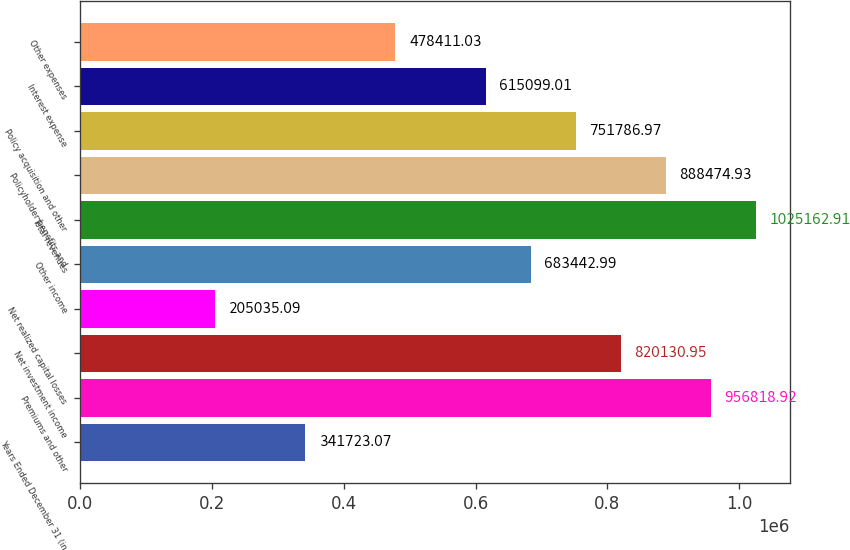<chart> <loc_0><loc_0><loc_500><loc_500><bar_chart><fcel>Years Ended December 31 (in<fcel>Premiums and other<fcel>Net investment income<fcel>Net realized capital losses<fcel>Other income<fcel>Total revenues<fcel>Policyholder benefits and<fcel>Policy acquisition and other<fcel>Interest expense<fcel>Other expenses<nl><fcel>341723<fcel>956819<fcel>820131<fcel>205035<fcel>683443<fcel>1.02516e+06<fcel>888475<fcel>751787<fcel>615099<fcel>478411<nl></chart> 